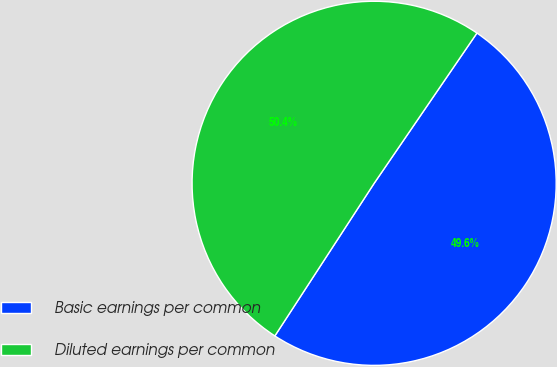<chart> <loc_0><loc_0><loc_500><loc_500><pie_chart><fcel>Basic earnings per common<fcel>Diluted earnings per common<nl><fcel>49.63%<fcel>50.37%<nl></chart> 